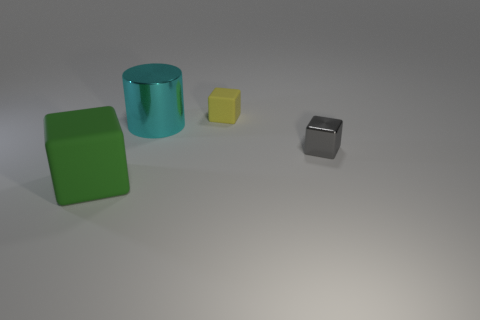Can you describe the texture of the objects? Certainly! All the objects in the image have a matte finish, which creates an even, non-glossy surface. This texture diffuses light, reducing shine and reflection, and gives a smooth tactile quality to the objects. 